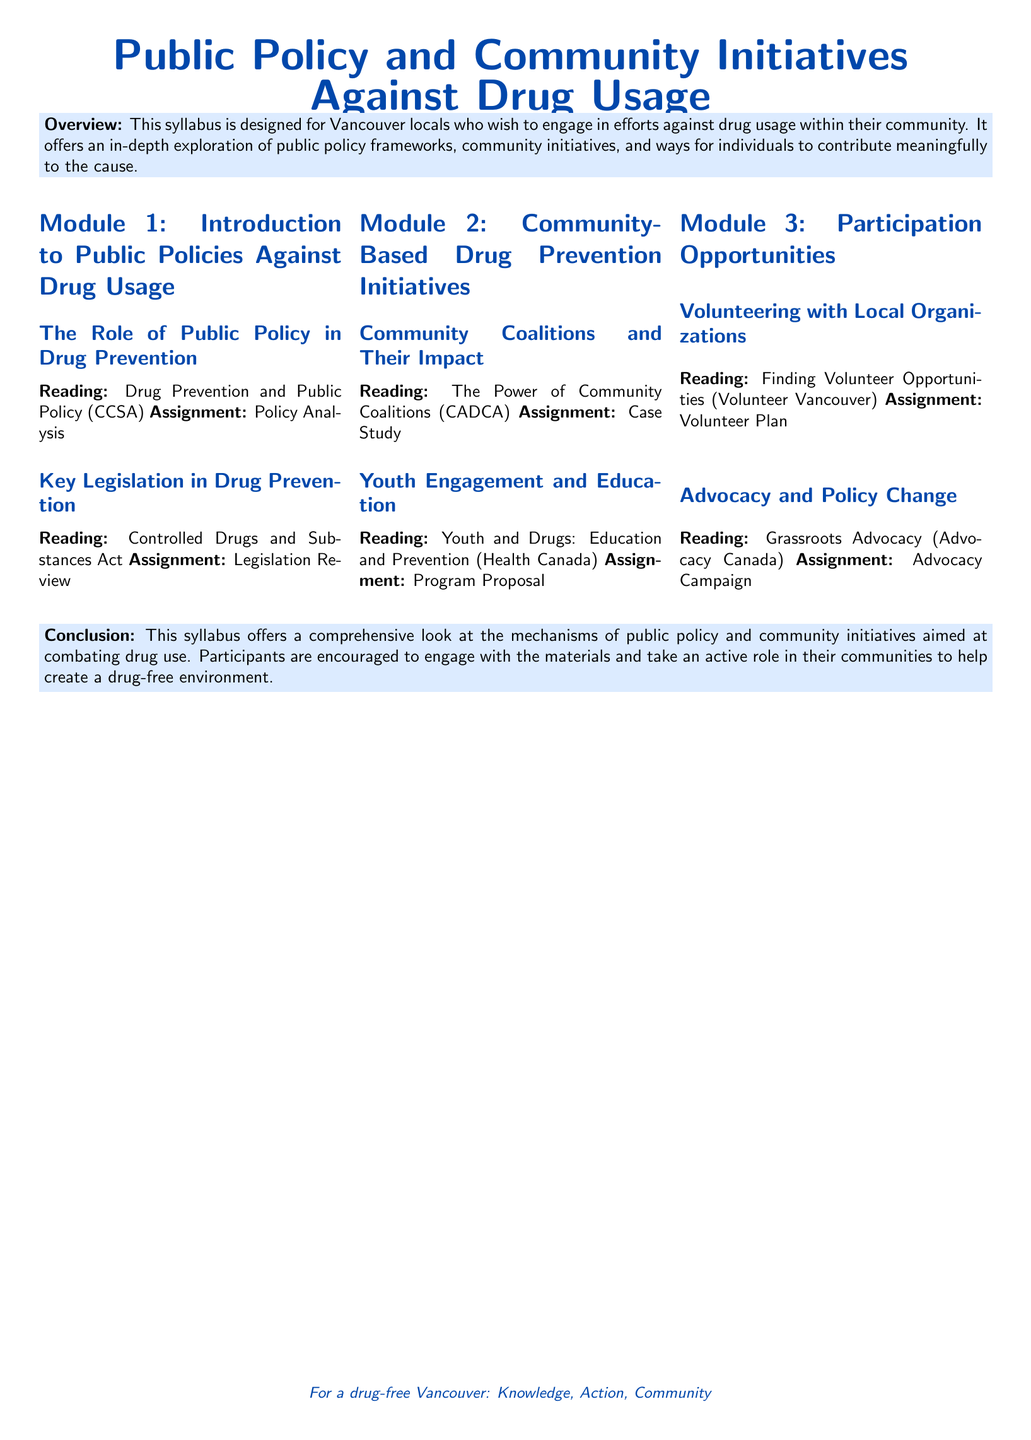What is the title of the syllabus? The title is the main heading of the document, which is prominently displayed.
Answer: Public Policy and Community Initiatives Against Drug Usage What is the focus of Module 1? Module 1 covers topics related to public policies specifically targeting drug usage prevention.
Answer: Introduction to Public Policies Against Drug Usage Which organization is referenced for volunteering opportunities? The document mentions an organization that assists locals in finding volunteer options, indicated in the participation section.
Answer: Volunteer Vancouver What is the reading material for the Youth Engagement and Education subsection? The document specifies a reading related to youth and drugs under this subsection.
Answer: Youth and Drugs: Education and Prevention What type of campaign is suggested under the Advocacy and Policy Change section? The syllabus prompts participants to engage in a specific type of campaign as part of their activities.
Answer: Advocacy Campaign What is the conclusion focused on? The conclusion summarizes the goal and encourages participation in community efforts to address drug usage.
Answer: A drug-free environment What kind of assignment is linked to the reading on community coalitions? Each subsection includes a task; the one for community coalitions isn't different in format.
Answer: Case Study How many modules are included in the syllabus? The syllabus outlines its structure by listing the modules at the beginning, focusing on specific themes.
Answer: Three 